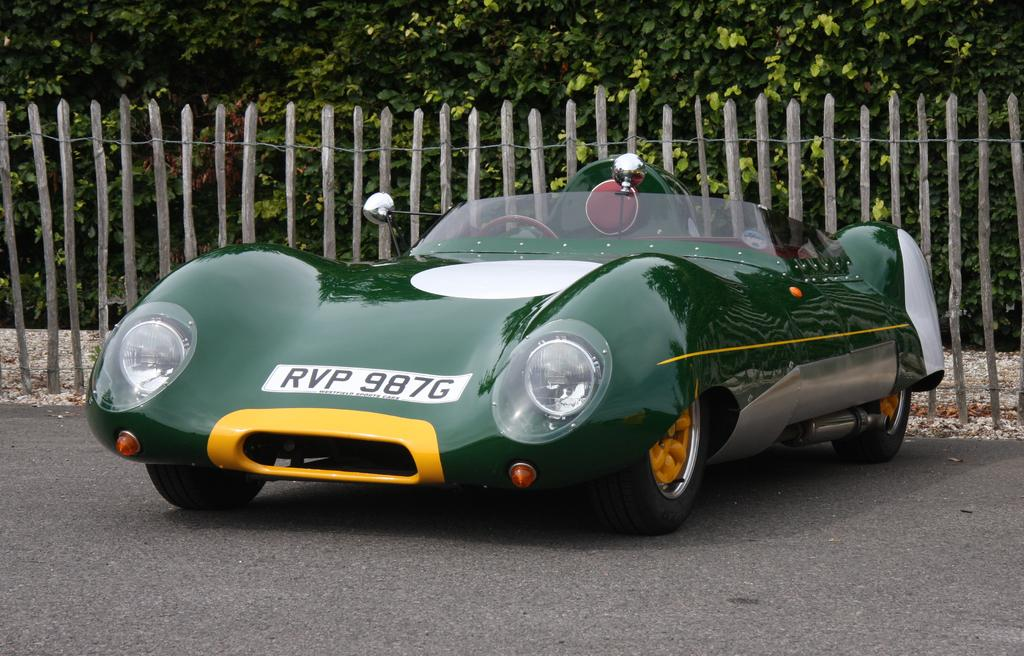What color is the car in the image? The car in the image is green. Where is the car located? The car is on the road. What is behind the car in the image? There is a fencing at the back of the car. What can be seen in the background of the image? There are many trees in the background of the image. Can you see any sparks coming from the car's exhaust in the image? There are no sparks visible in the image. 